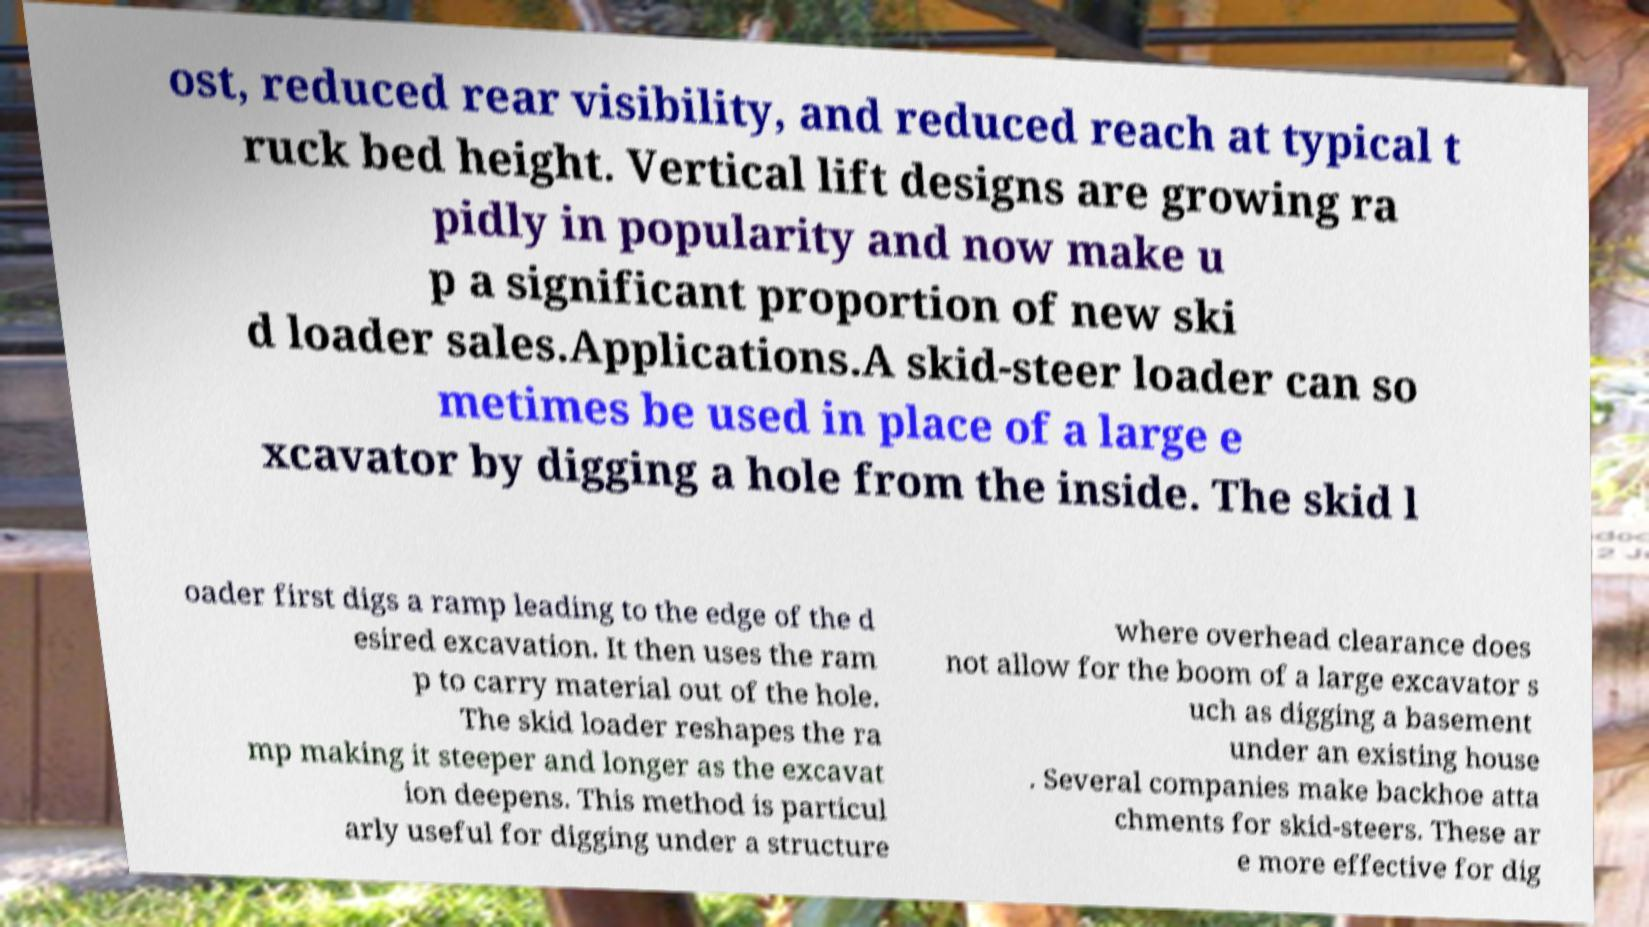For documentation purposes, I need the text within this image transcribed. Could you provide that? ost, reduced rear visibility, and reduced reach at typical t ruck bed height. Vertical lift designs are growing ra pidly in popularity and now make u p a significant proportion of new ski d loader sales.Applications.A skid-steer loader can so metimes be used in place of a large e xcavator by digging a hole from the inside. The skid l oader first digs a ramp leading to the edge of the d esired excavation. It then uses the ram p to carry material out of the hole. The skid loader reshapes the ra mp making it steeper and longer as the excavat ion deepens. This method is particul arly useful for digging under a structure where overhead clearance does not allow for the boom of a large excavator s uch as digging a basement under an existing house . Several companies make backhoe atta chments for skid-steers. These ar e more effective for dig 